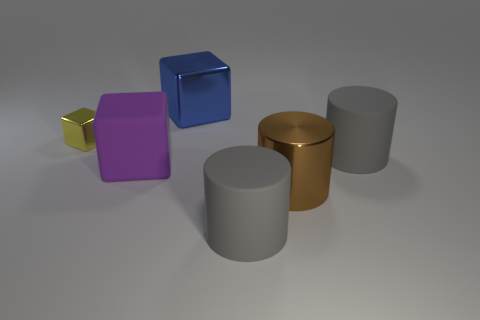What number of things are gray rubber cylinders or gray cylinders right of the brown object? There are two gray cylinders located to the right of the brown cylinder. These two objects fit the description of being either gray rubber cylinders or gray cylinders as specified. 